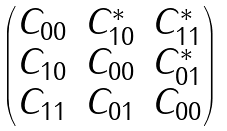Convert formula to latex. <formula><loc_0><loc_0><loc_500><loc_500>\begin{pmatrix} C _ { 0 0 } & C _ { 1 0 } ^ { * } & C _ { 1 1 } ^ { * } \\ C _ { 1 0 } & C _ { 0 0 } & C _ { 0 1 } ^ { * } \\ C _ { 1 1 } & C _ { 0 1 } & C _ { 0 0 } \\ \end{pmatrix}</formula> 